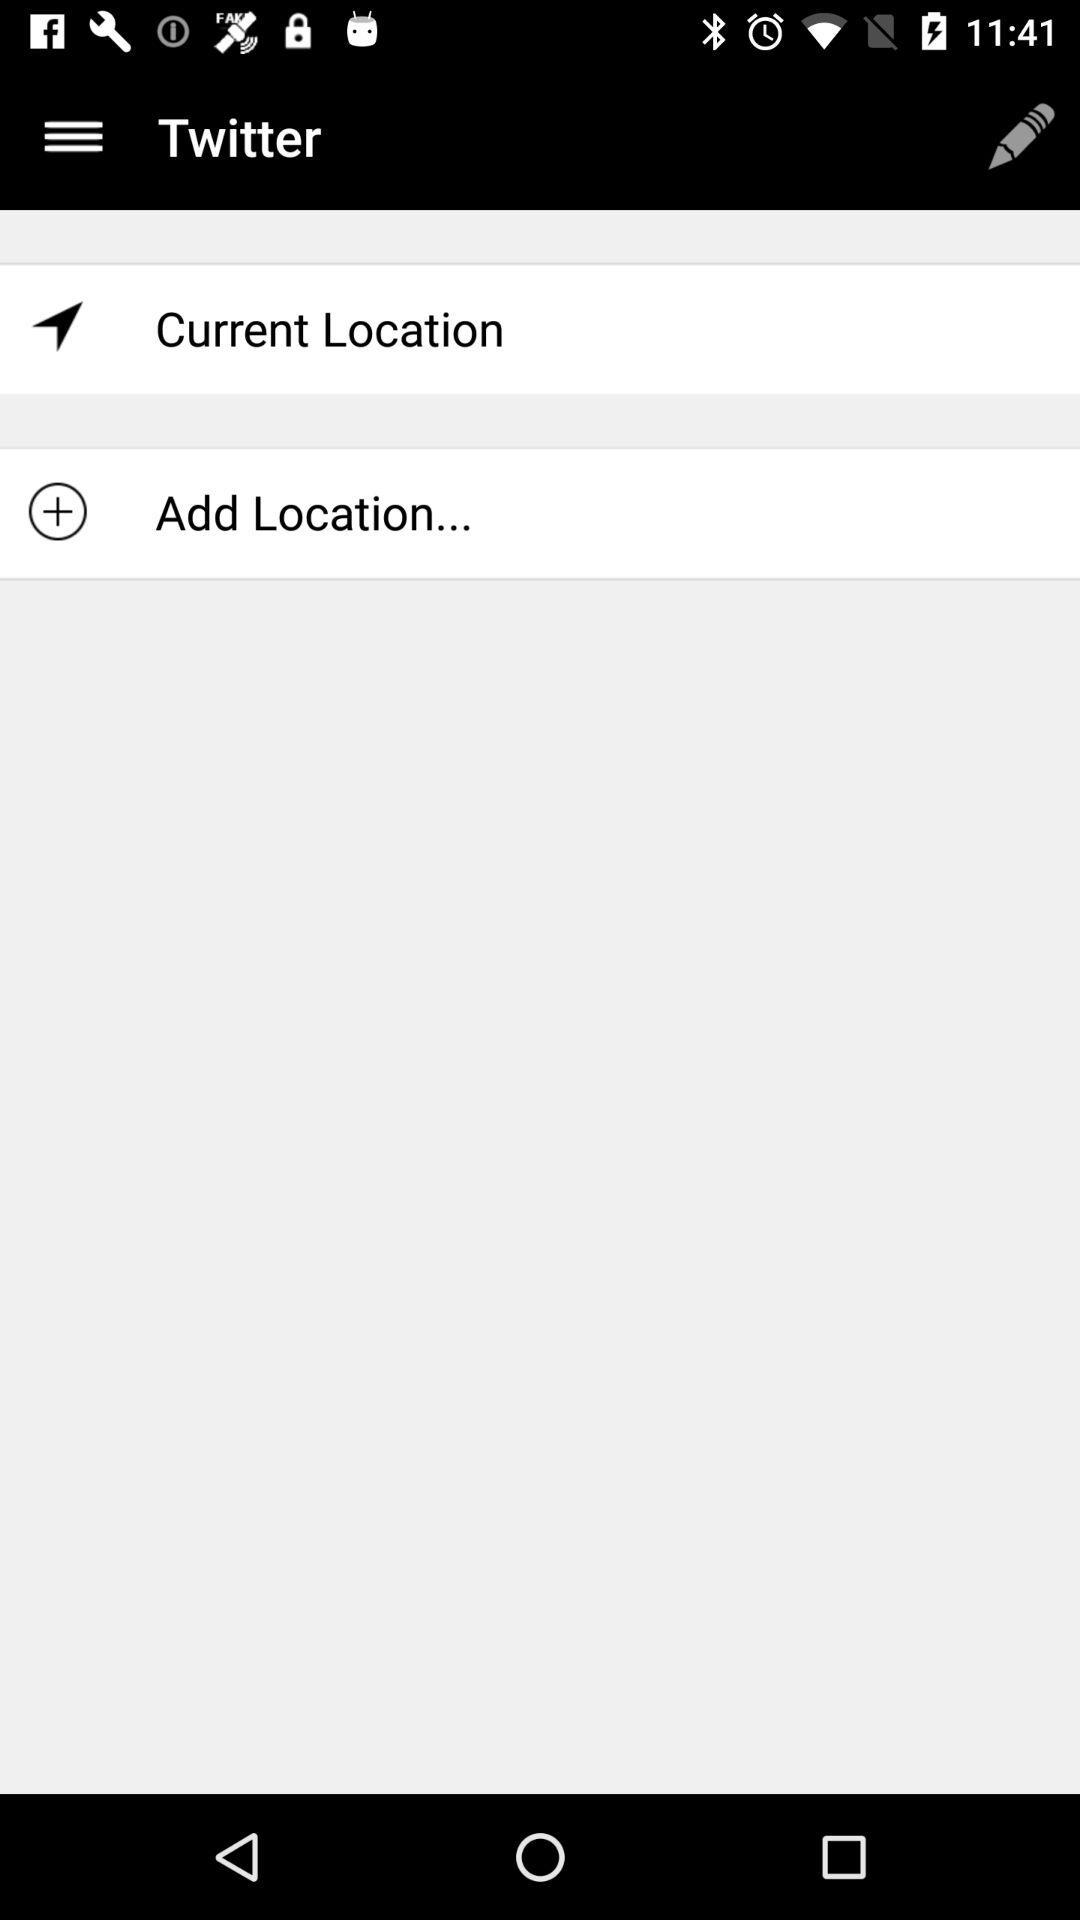What is the name of the application? The application name is "Twitter". 